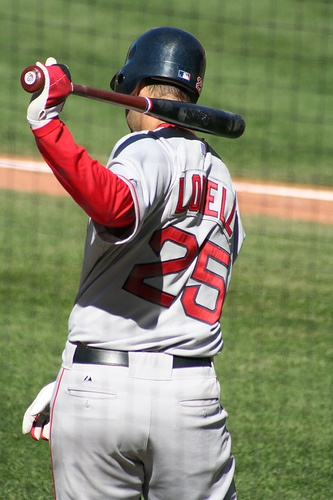Describe the objects in this image and their specific colors. I can see people in olive, lightgray, black, darkgray, and gray tones and baseball bat in olive, black, maroon, gray, and navy tones in this image. 